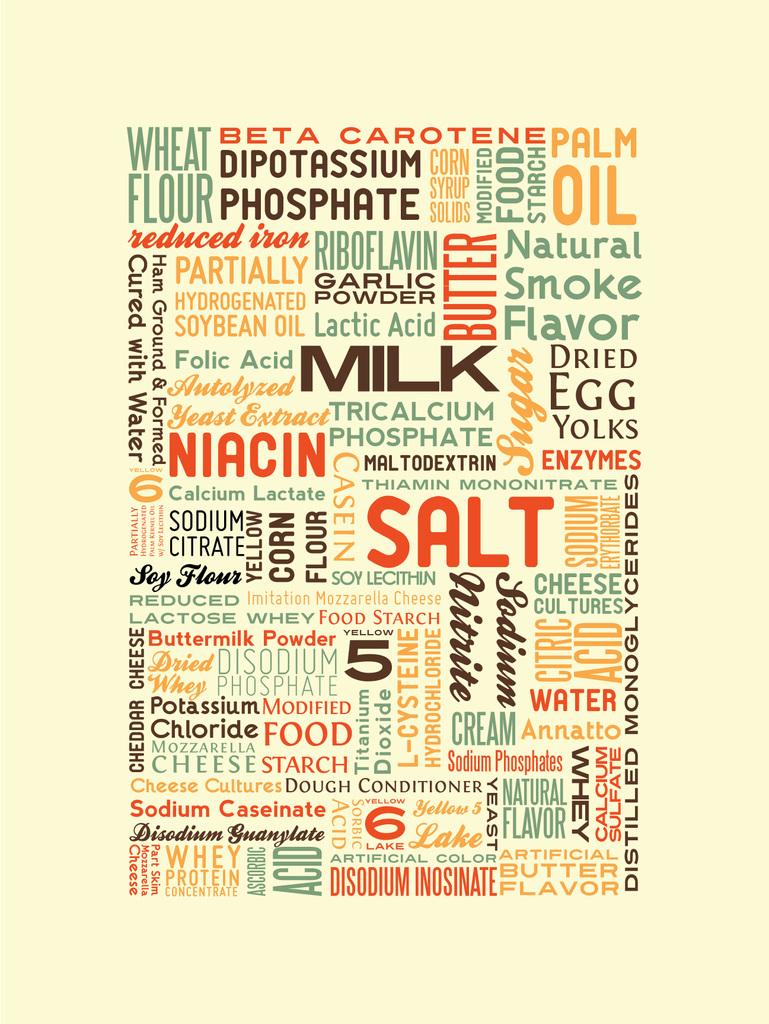What big word is in orange and begins with an s?
Your answer should be compact. Salt. 